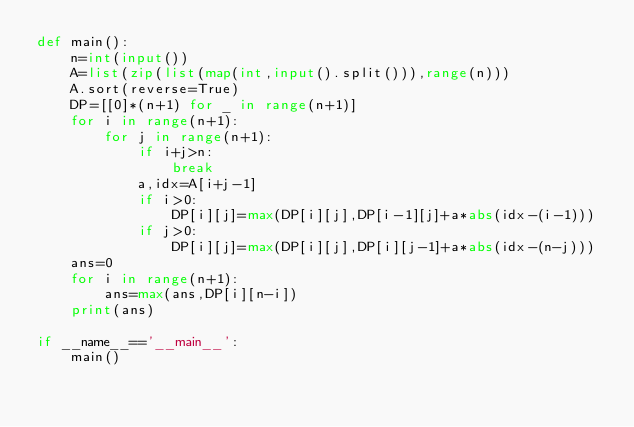<code> <loc_0><loc_0><loc_500><loc_500><_Python_>def main():
    n=int(input())
    A=list(zip(list(map(int,input().split())),range(n)))
    A.sort(reverse=True)
    DP=[[0]*(n+1) for _ in range(n+1)]
    for i in range(n+1):
        for j in range(n+1):
            if i+j>n:
                break
            a,idx=A[i+j-1]
            if i>0:
                DP[i][j]=max(DP[i][j],DP[i-1][j]+a*abs(idx-(i-1)))
            if j>0:
                DP[i][j]=max(DP[i][j],DP[i][j-1]+a*abs(idx-(n-j)))
    ans=0
    for i in range(n+1):
        ans=max(ans,DP[i][n-i])
    print(ans)
    
if __name__=='__main__':
    main()</code> 